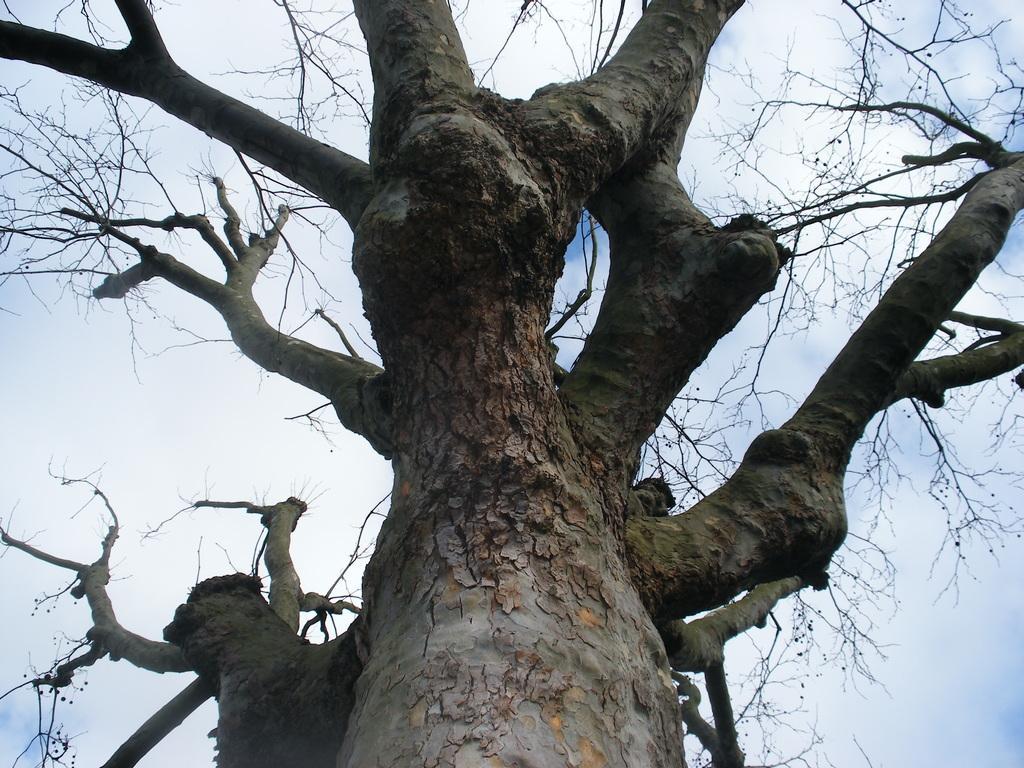Could you give a brief overview of what you see in this image? Here we can see dried tree. Sky is cloudy. 